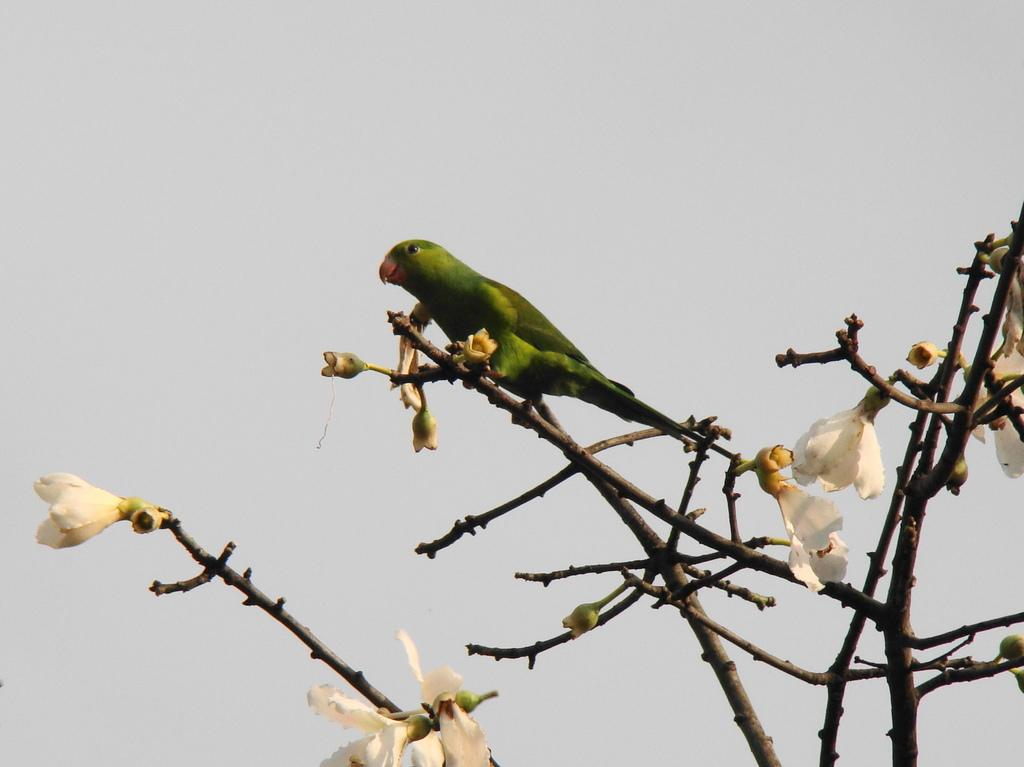What is the main subject in the center of the image? There is a parrot in the center of the image. What can be seen at the bottom of the image? Flowers, branches, and buds are present at the bottom of the image. What is visible in the background of the image? The sky is visible in the background of the image. What type of locket can be seen hanging from the parrot's neck in the image? There is no locket present in the image; the parrot is not wearing any jewelry. What material is the lead used for in the image? There is no lead present in the image, so it's not possible to determine what material it might be used for. 